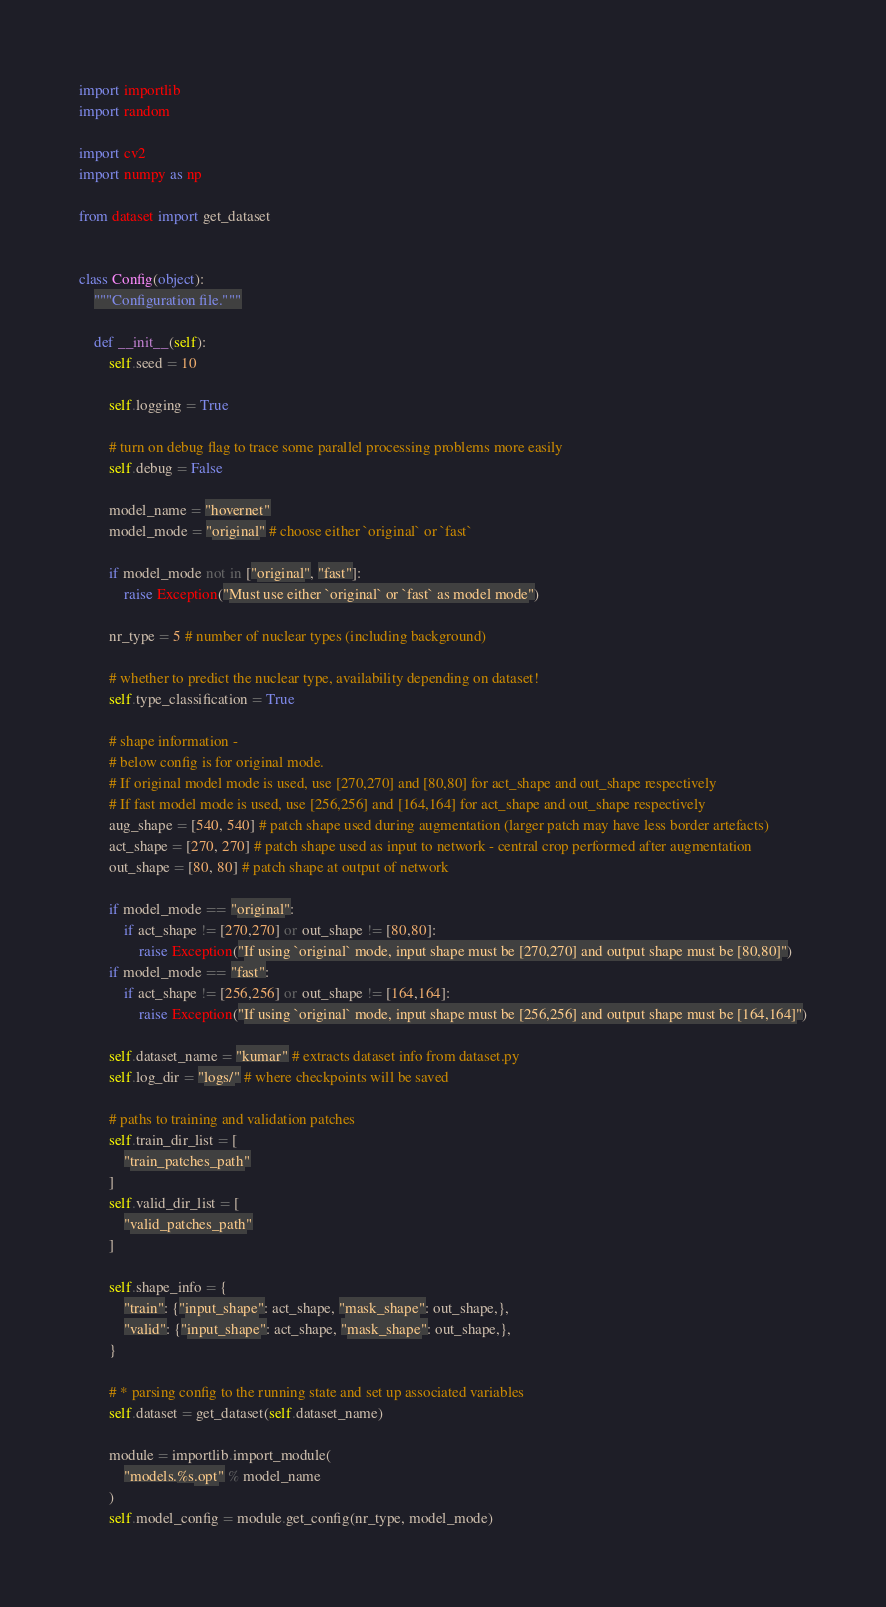<code> <loc_0><loc_0><loc_500><loc_500><_Python_>import importlib
import random

import cv2
import numpy as np

from dataset import get_dataset


class Config(object):
    """Configuration file."""

    def __init__(self):
        self.seed = 10

        self.logging = True

        # turn on debug flag to trace some parallel processing problems more easily
        self.debug = False

        model_name = "hovernet"
        model_mode = "original" # choose either `original` or `fast`

        if model_mode not in ["original", "fast"]:
            raise Exception("Must use either `original` or `fast` as model mode")

        nr_type = 5 # number of nuclear types (including background)

        # whether to predict the nuclear type, availability depending on dataset!
        self.type_classification = True

        # shape information - 
        # below config is for original mode. 
        # If original model mode is used, use [270,270] and [80,80] for act_shape and out_shape respectively
        # If fast model mode is used, use [256,256] and [164,164] for act_shape and out_shape respectively
        aug_shape = [540, 540] # patch shape used during augmentation (larger patch may have less border artefacts)
        act_shape = [270, 270] # patch shape used as input to network - central crop performed after augmentation
        out_shape = [80, 80] # patch shape at output of network

        if model_mode == "original":
            if act_shape != [270,270] or out_shape != [80,80]:
                raise Exception("If using `original` mode, input shape must be [270,270] and output shape must be [80,80]")
        if model_mode == "fast":
            if act_shape != [256,256] or out_shape != [164,164]:
                raise Exception("If using `original` mode, input shape must be [256,256] and output shape must be [164,164]")

        self.dataset_name = "kumar" # extracts dataset info from dataset.py
        self.log_dir = "logs/" # where checkpoints will be saved

        # paths to training and validation patches
        self.train_dir_list = [
            "train_patches_path"
        ]
        self.valid_dir_list = [
            "valid_patches_path"
        ]

        self.shape_info = {
            "train": {"input_shape": act_shape, "mask_shape": out_shape,},
            "valid": {"input_shape": act_shape, "mask_shape": out_shape,},
        }

        # * parsing config to the running state and set up associated variables
        self.dataset = get_dataset(self.dataset_name)

        module = importlib.import_module(
            "models.%s.opt" % model_name
        )
        self.model_config = module.get_config(nr_type, model_mode)
</code> 